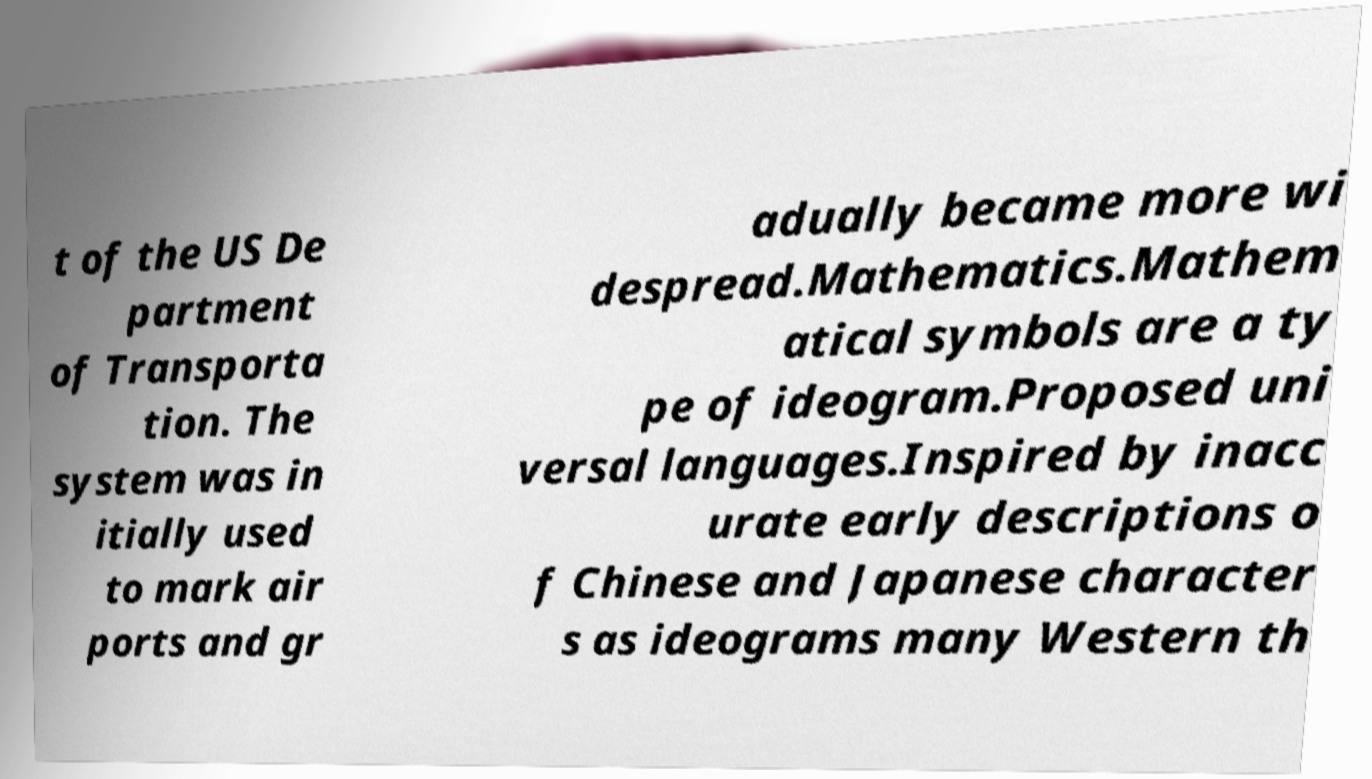Could you extract and type out the text from this image? t of the US De partment of Transporta tion. The system was in itially used to mark air ports and gr adually became more wi despread.Mathematics.Mathem atical symbols are a ty pe of ideogram.Proposed uni versal languages.Inspired by inacc urate early descriptions o f Chinese and Japanese character s as ideograms many Western th 